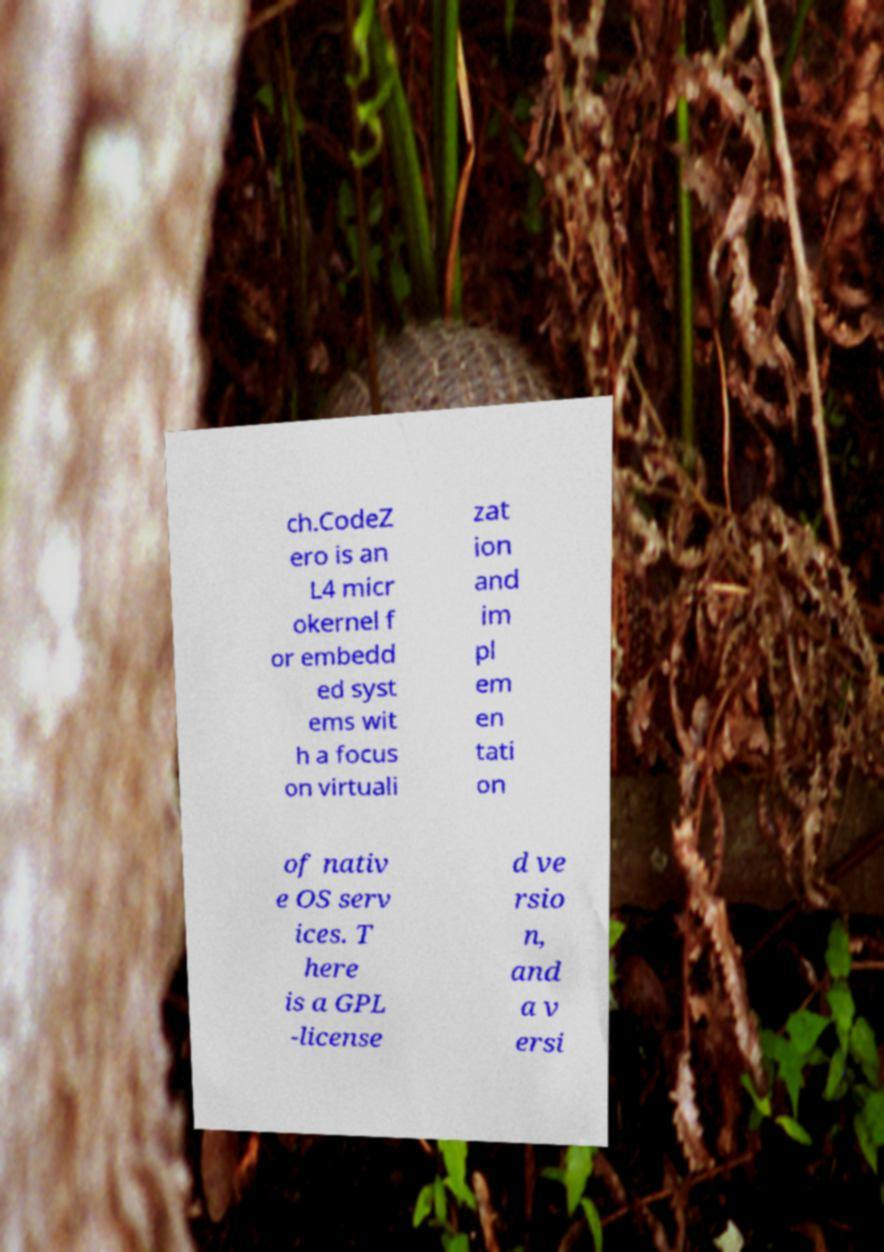Can you read and provide the text displayed in the image?This photo seems to have some interesting text. Can you extract and type it out for me? ch.CodeZ ero is an L4 micr okernel f or embedd ed syst ems wit h a focus on virtuali zat ion and im pl em en tati on of nativ e OS serv ices. T here is a GPL -license d ve rsio n, and a v ersi 